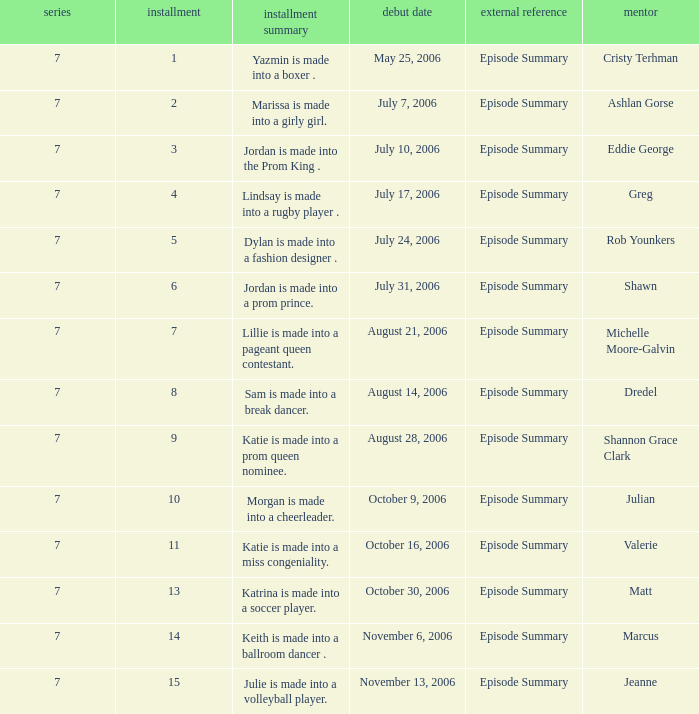How many episodes have Valerie? 1.0. 